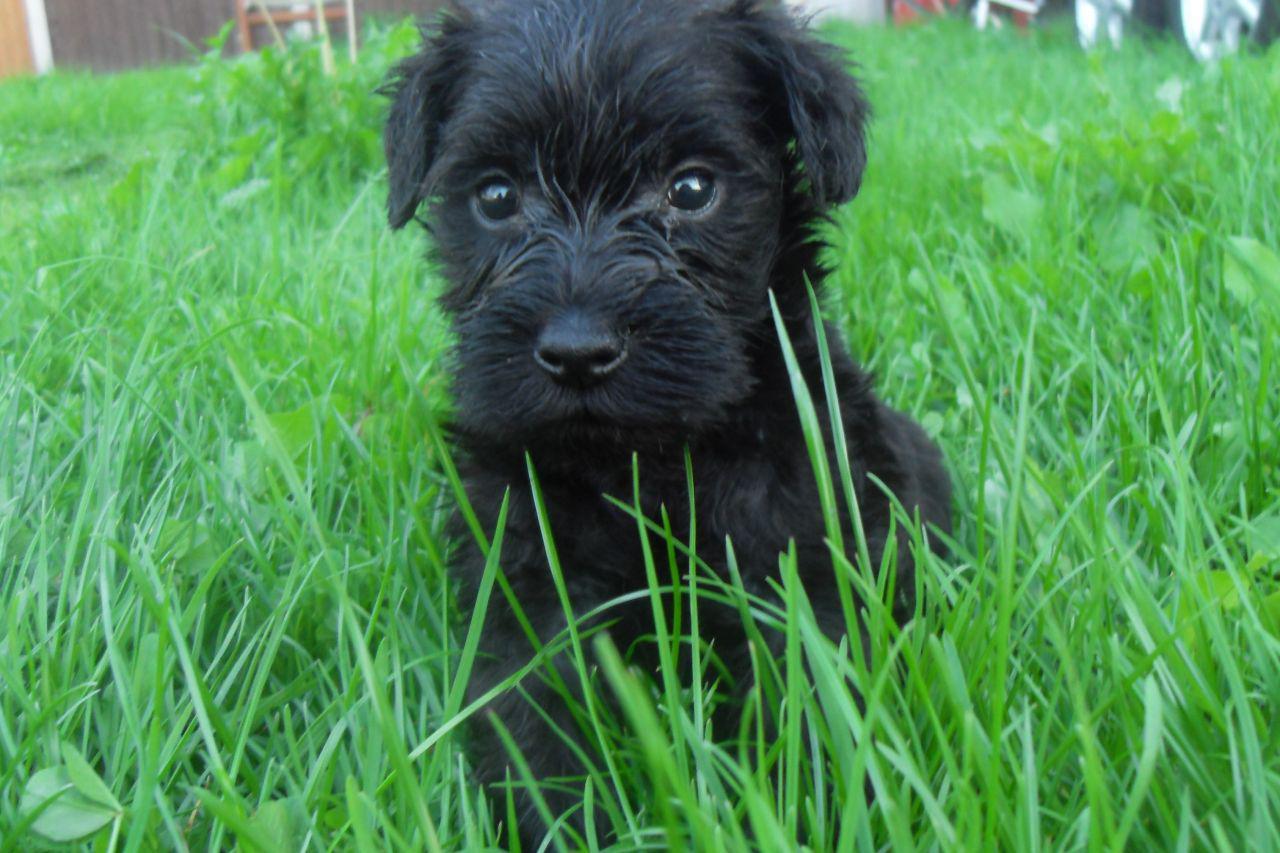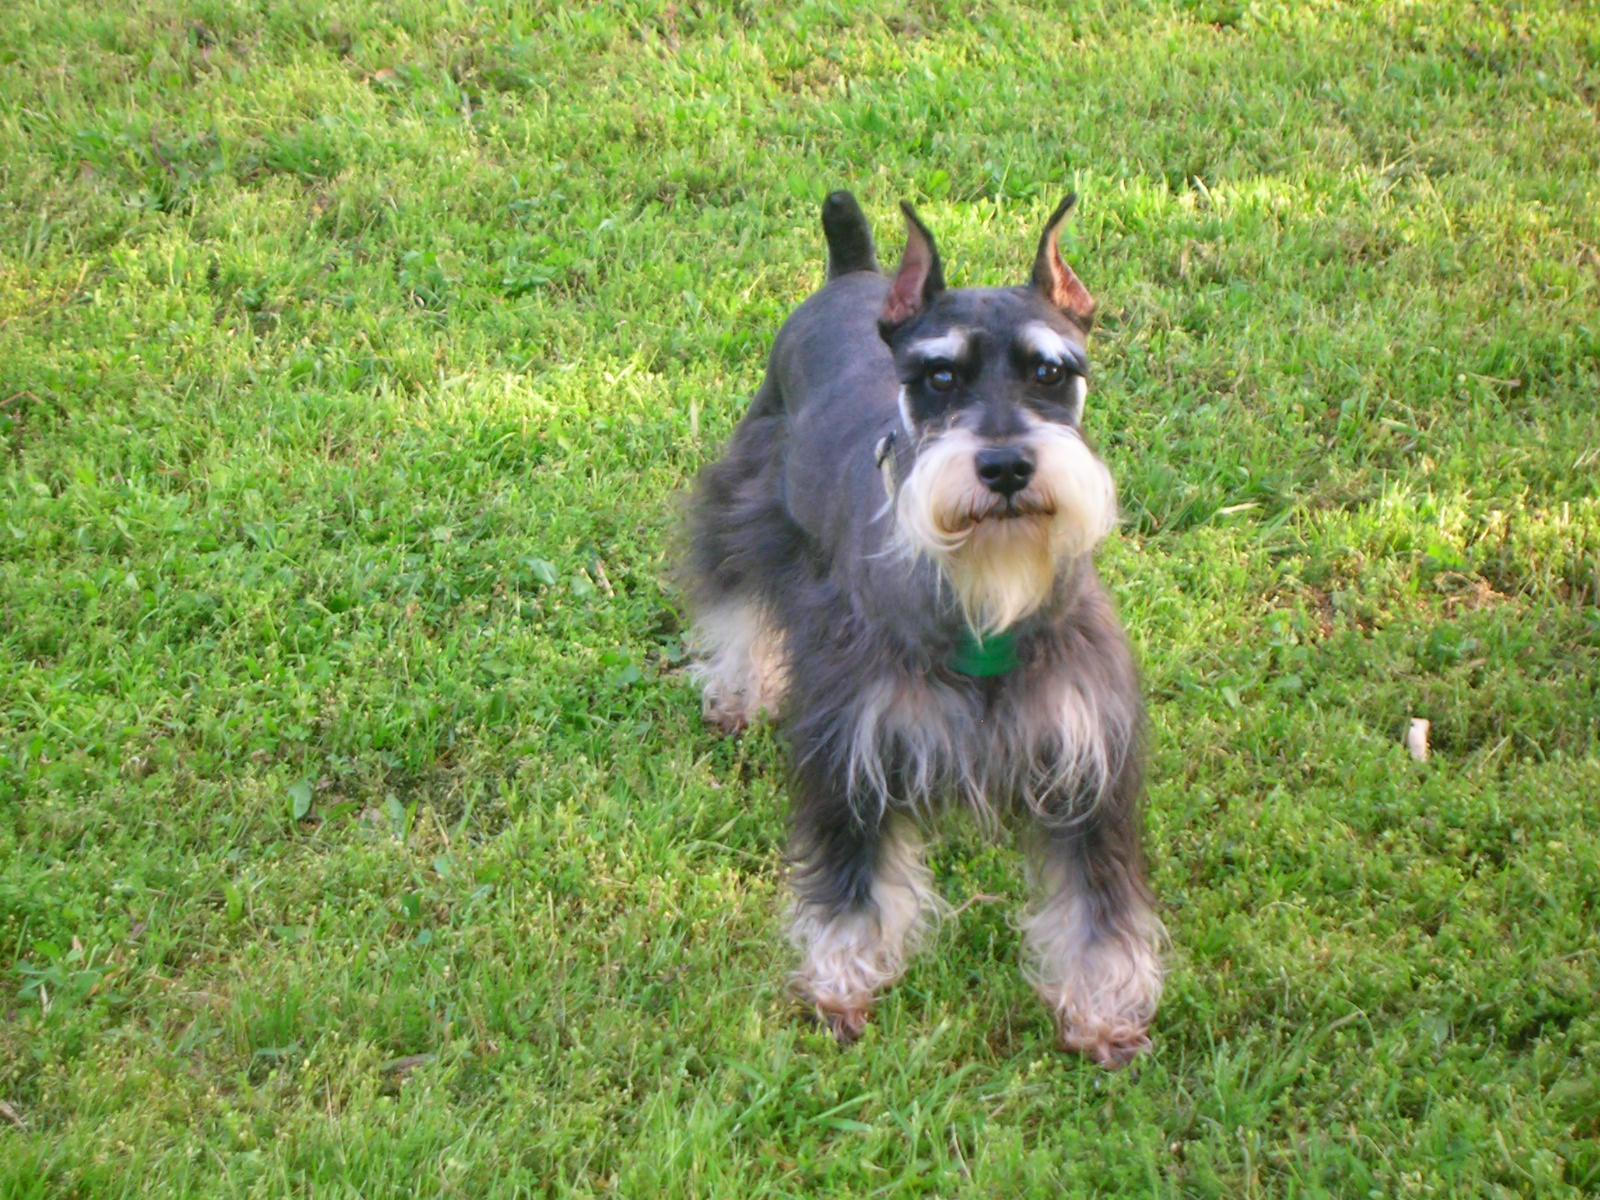The first image is the image on the left, the second image is the image on the right. Examine the images to the left and right. Is the description "The right image has a dog with it's from feet propped on stone while looking at the camera" accurate? Answer yes or no. No. The first image is the image on the left, the second image is the image on the right. For the images shown, is this caption "In one image there is a dog sitting in grass." true? Answer yes or no. Yes. 